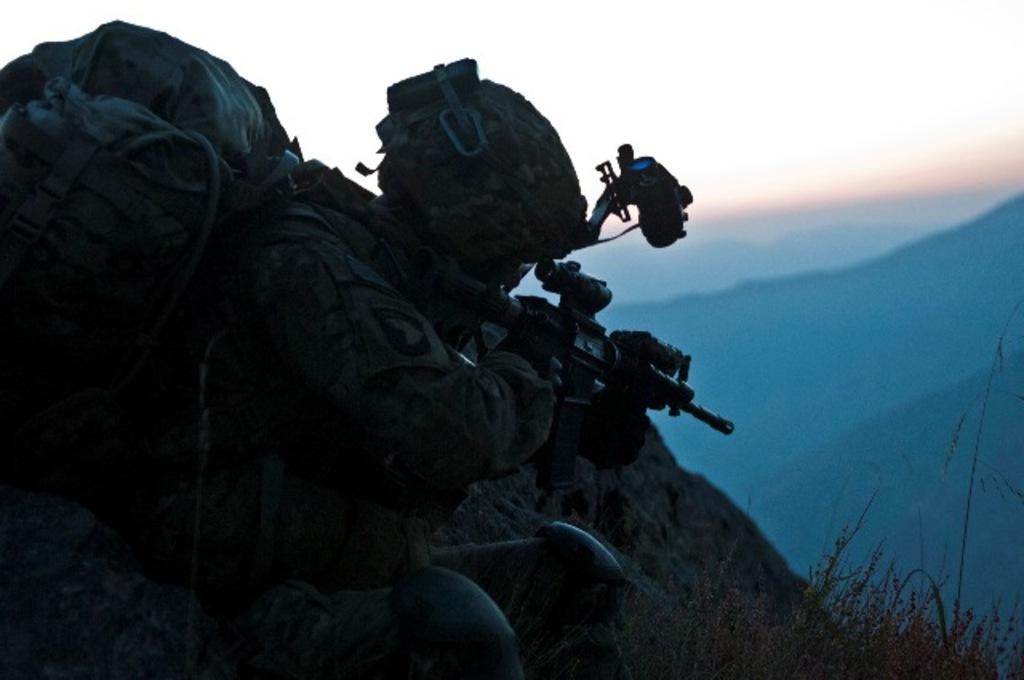Could you give a brief overview of what you see in this image? There is a man holding a gun and carrying a bag and wore helmet and we can see plants. In the background we can see hills and sky. 